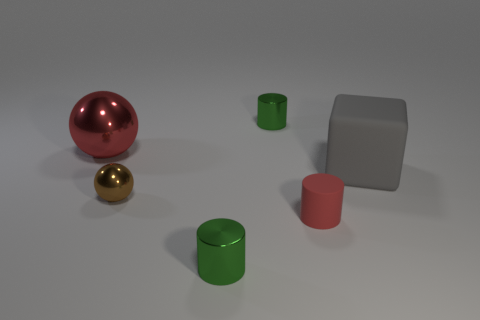Subtract all matte cylinders. How many cylinders are left? 2 Add 3 small matte cylinders. How many objects exist? 9 Subtract 1 balls. How many balls are left? 1 Subtract all brown balls. How many balls are left? 1 Subtract all green cubes. How many red spheres are left? 1 Subtract all small red things. Subtract all small purple spheres. How many objects are left? 5 Add 5 brown things. How many brown things are left? 6 Add 2 tiny blue metal things. How many tiny blue metal things exist? 2 Subtract 0 yellow cubes. How many objects are left? 6 Subtract all cubes. How many objects are left? 5 